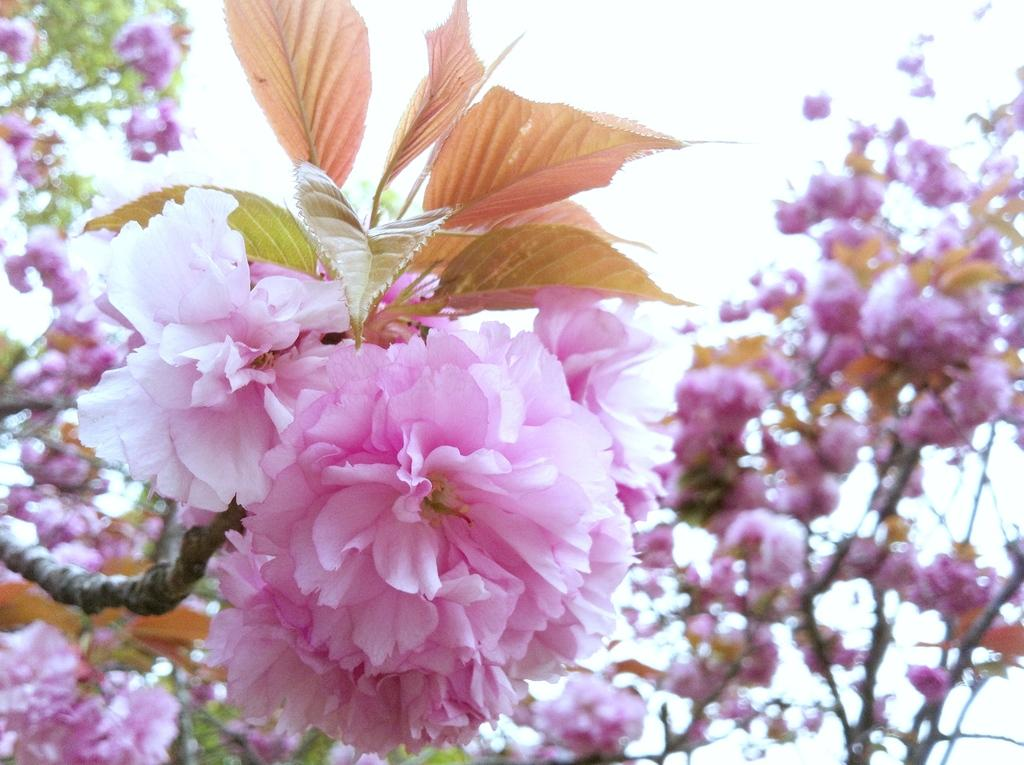What type of trees are present in the image? There are cherry blossom trees in the image. What is the primary feature of these trees that can be observed in the image? The cherry blossom trees are known for their beautiful pink flowers. Can you describe the setting in which the cherry blossom trees are located? The image does not provide enough information to determine the specific setting or location of the cherry blossom trees. How many answers are hidden in the bedroom in the image? There is no bedroom present in the image, and therefore no answers can be hidden within it. 